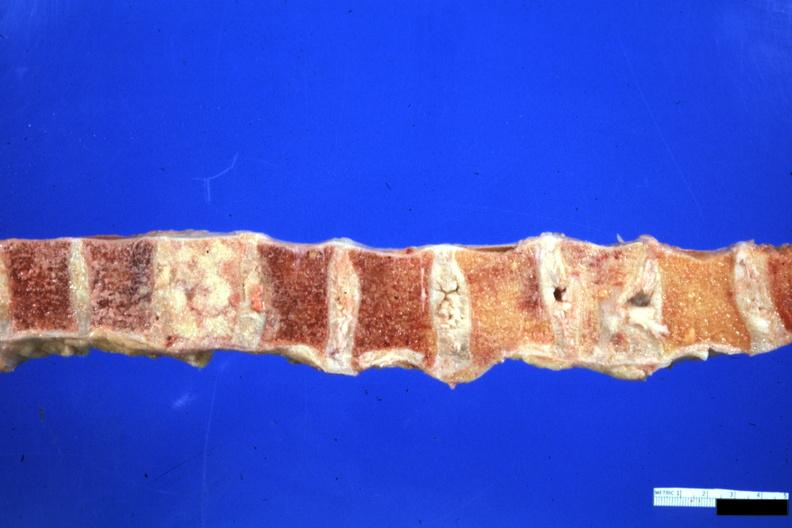s one collapsed vertebra and one filled with neoplasm looks like breast carcinoma but is an unclassified lymphoma?
Answer the question using a single word or phrase. Yes 